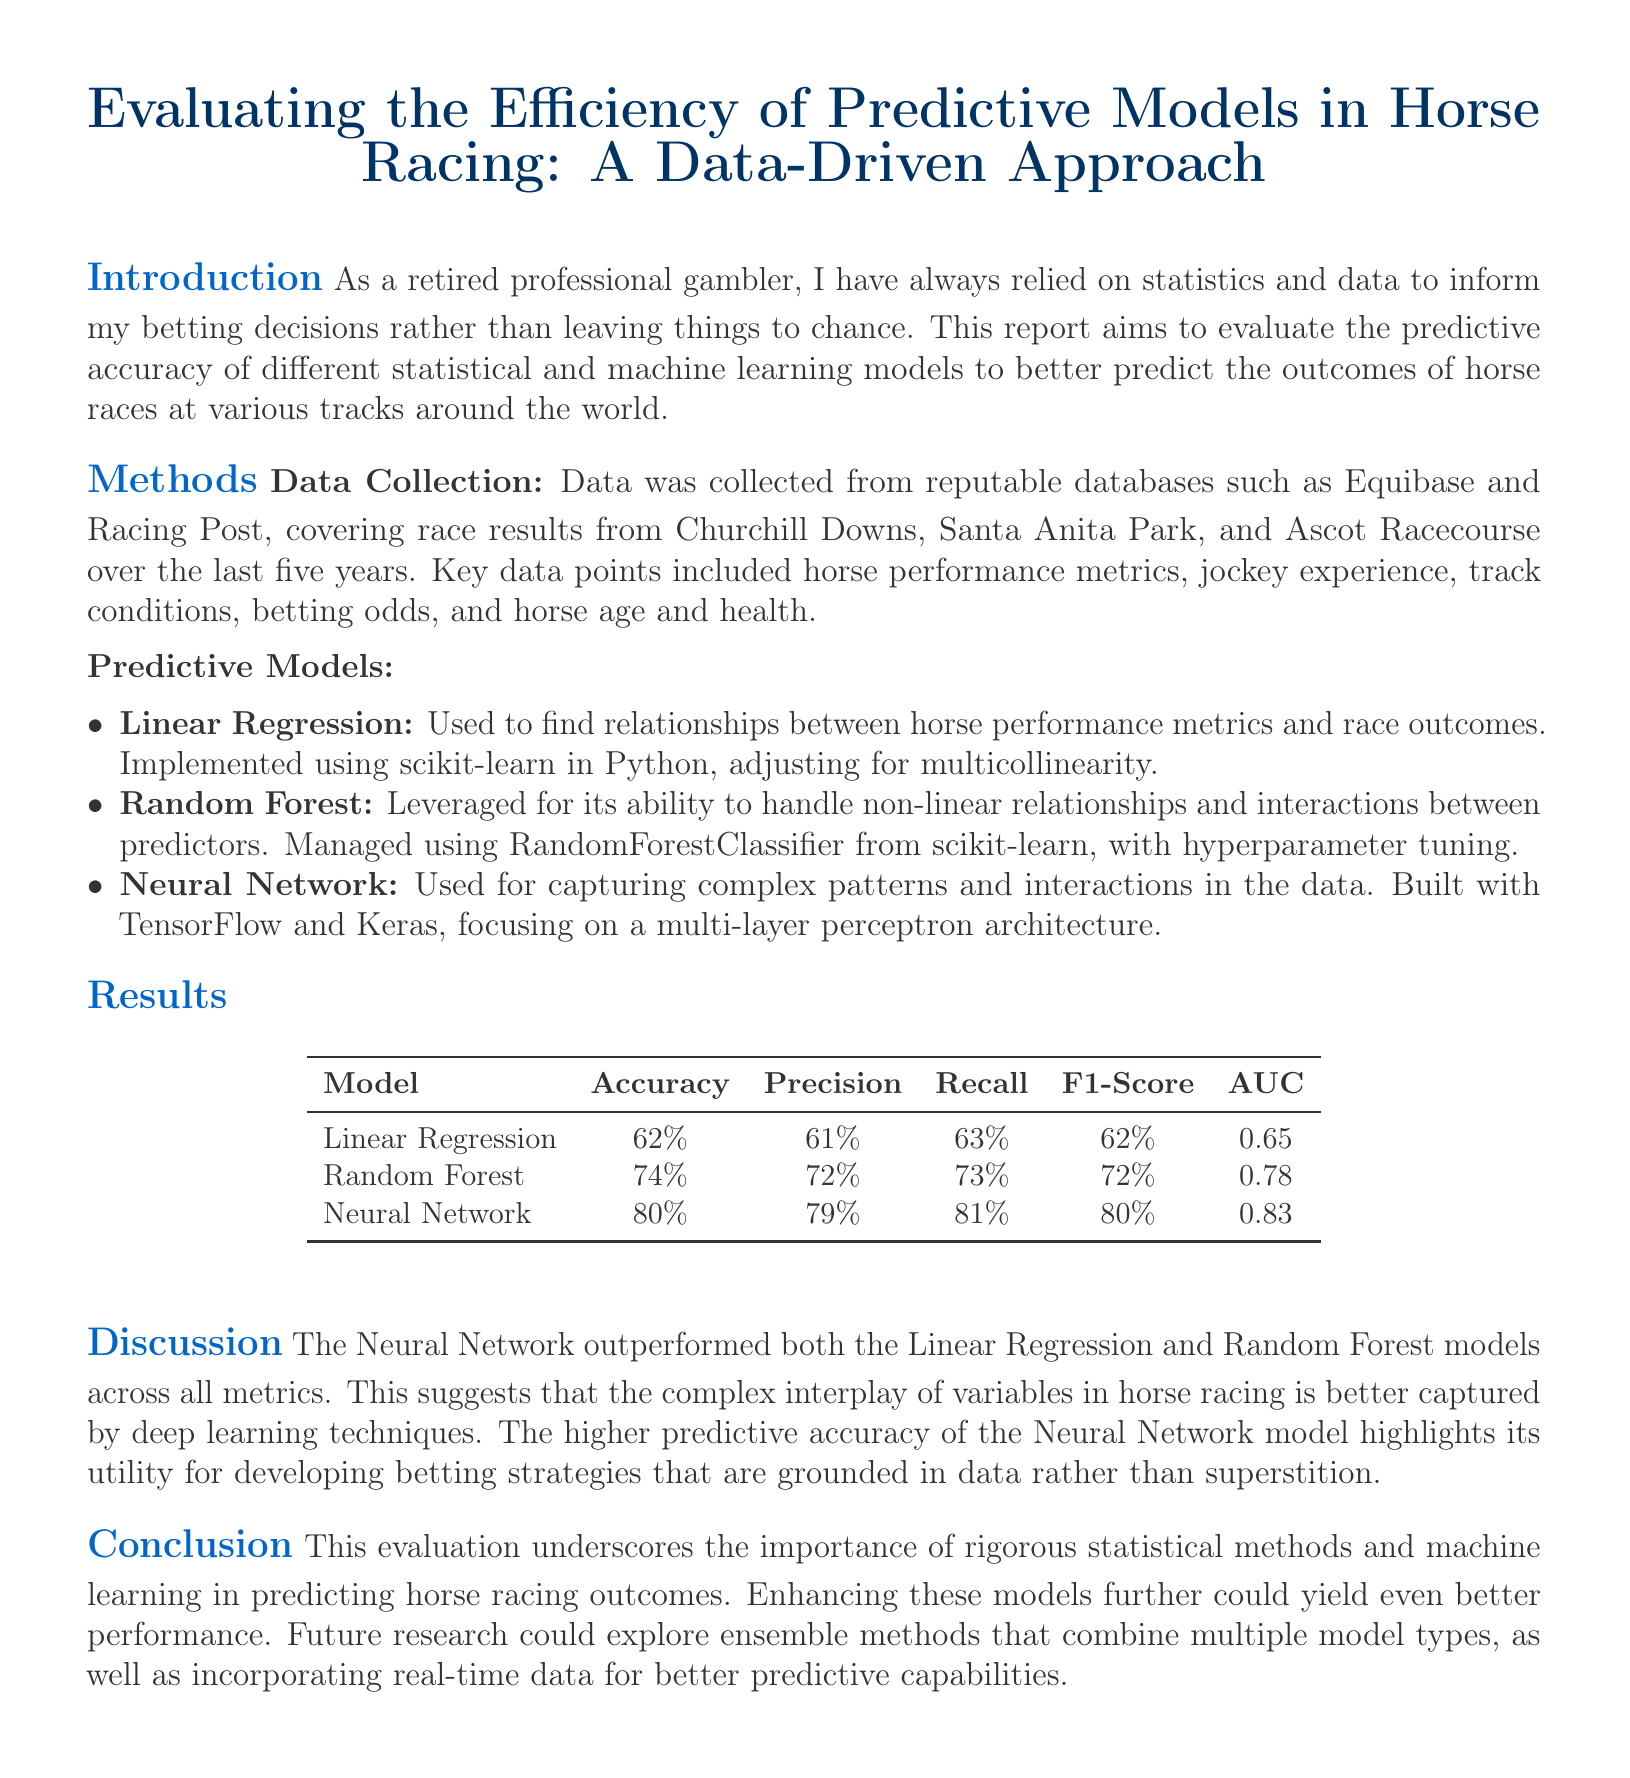What is the highest accuracy achieved by a model? The highest accuracy among the predictive models is found in the Neural Network, with an accuracy of 80%.
Answer: 80% Which model had the lowest precision? The model with the lowest precision value is Linear Regression, which had a precision of 61%.
Answer: 61% What type of architecture was used for the Neural Network? The Neural Network was built focusing on a multi-layer perceptron architecture, which is a standard design for neural networks.
Answer: multi-layer perceptron How many tracks were noted for data collection? The report specifies three tracks were used for data collection, including Churchill Downs, Santa Anita Park, and Ascot Racecourse.
Answer: three What was the F1-score of the Random Forest model? The F1-score of the Random Forest model is shown in the results section as 72%.
Answer: 72% Which predictive model scored the highest in terms of AUC? Among the models evaluated, the Neural Network scored the highest AUC value of 0.83, indicating better performance.
Answer: 0.83 What is the purpose of the report? The report aims to evaluate the predictive accuracy of different statistical and machine learning models to predict horse racing outcomes.
Answer: evaluate predictive accuracy Which database was mentioned as a source for data collection? Equibase is one of the reputable databases mentioned for collecting race results data in the report.
Answer: Equibase What future research direction is suggested in the conclusion? The conclusion suggests exploring ensemble methods that combine multiple model types for improved performance.
Answer: ensemble methods 